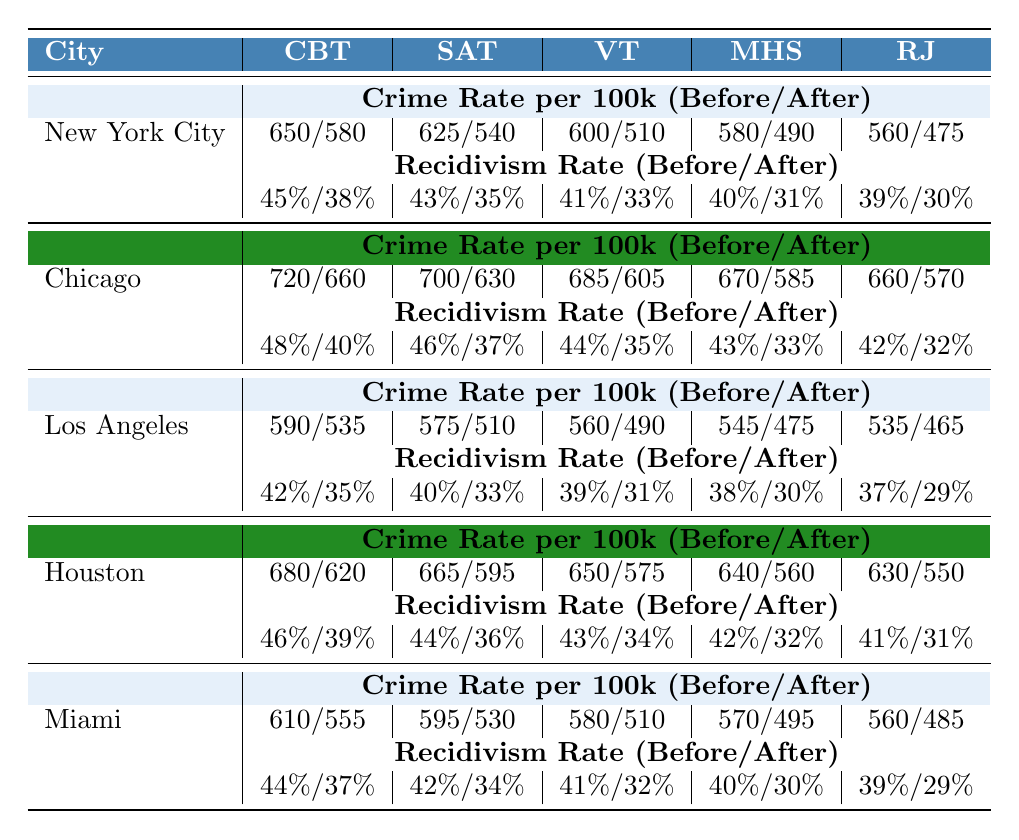what was the crime rate for New York City before the Cognitive Behavioral Therapy program? According to the table, the crime rate in New York City before the Cognitive Behavioral Therapy program was 650 per 100k.
Answer: 650 what are the recidivism rates in Chicago before and after Substance Abuse Treatment? From the table, Chicago's recidivism rate before the program was 46%, and after, it was 37%.
Answer: 46% before, 37% after which city had the highest recidivism rate before implementing vocational training? By examining the table, Chicago had the highest recidivism rate before implementing vocational training at 44%.
Answer: Chicago what was the difference in crime rates for Los Angeles before and after Mental Health Support? The crime rate in Los Angeles before Mental Health Support was 545 per 100k and after was 475 per 100k. The difference is 545 - 475 = 70.
Answer: 70 which rehabilitation program had the lowest crime rate after implementation in Miami? Looking at the table, Miami had the lowest crime rate after implementing Restorative Justice at 485 per 100k.
Answer: Restorative Justice did all cities experience a decrease in recidivism rates after implementing their programs? Yes, all cities shown in the table had lower recidivism rates after implementing their rehabilitation programs.
Answer: Yes what is the average crime rate per 100k across all cities after implementing Vocational Training? The after crime rates for Vocational Training are 510 (NYC), 605 (Chicago), 490 (LA), 575 (Houston), and 510 (Miami). The sum is 510 + 605 + 490 + 575 + 510 = 2890. The average is 2890 / 5 = 578.
Answer: 578 which city showed the greatest improvement in recidivism rates after implementing Cognitive Behavioral Therapy? The recidivism rates for New York City before and after were 45% and 38%, respectively, showing a decrease of 7%.
Answer: New York City how did the crime rate change in Houston from before to after Mental Health Support program? Houston's crime rate before Mental Health Support was 640 per 100k and after it dropped to 560 per 100k, resulting in a decrease of 80.
Answer: Decrease of 80 which city had the highest program effectiveness score for Vocational Training? By referring to the table, Los Angeles had the highest effectiveness score for Vocational Training at 7.
Answer: Los Angeles 